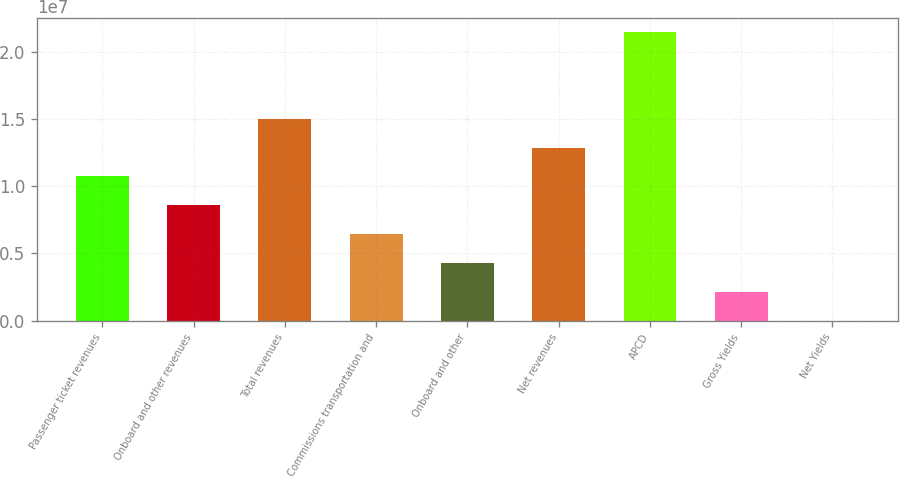<chart> <loc_0><loc_0><loc_500><loc_500><bar_chart><fcel>Passenger ticket revenues<fcel>Onboard and other revenues<fcel>Total revenues<fcel>Commissions transportation and<fcel>Onboard and other<fcel>Net revenues<fcel>APCD<fcel>Gross Yields<fcel>Net Yields<nl><fcel>1.07197e+07<fcel>8.57581e+06<fcel>1.50075e+07<fcel>6.4319e+06<fcel>4.28799e+06<fcel>1.28636e+07<fcel>2.14393e+07<fcel>2.14407e+06<fcel>160.1<nl></chart> 